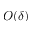<formula> <loc_0><loc_0><loc_500><loc_500>O ( \delta )</formula> 